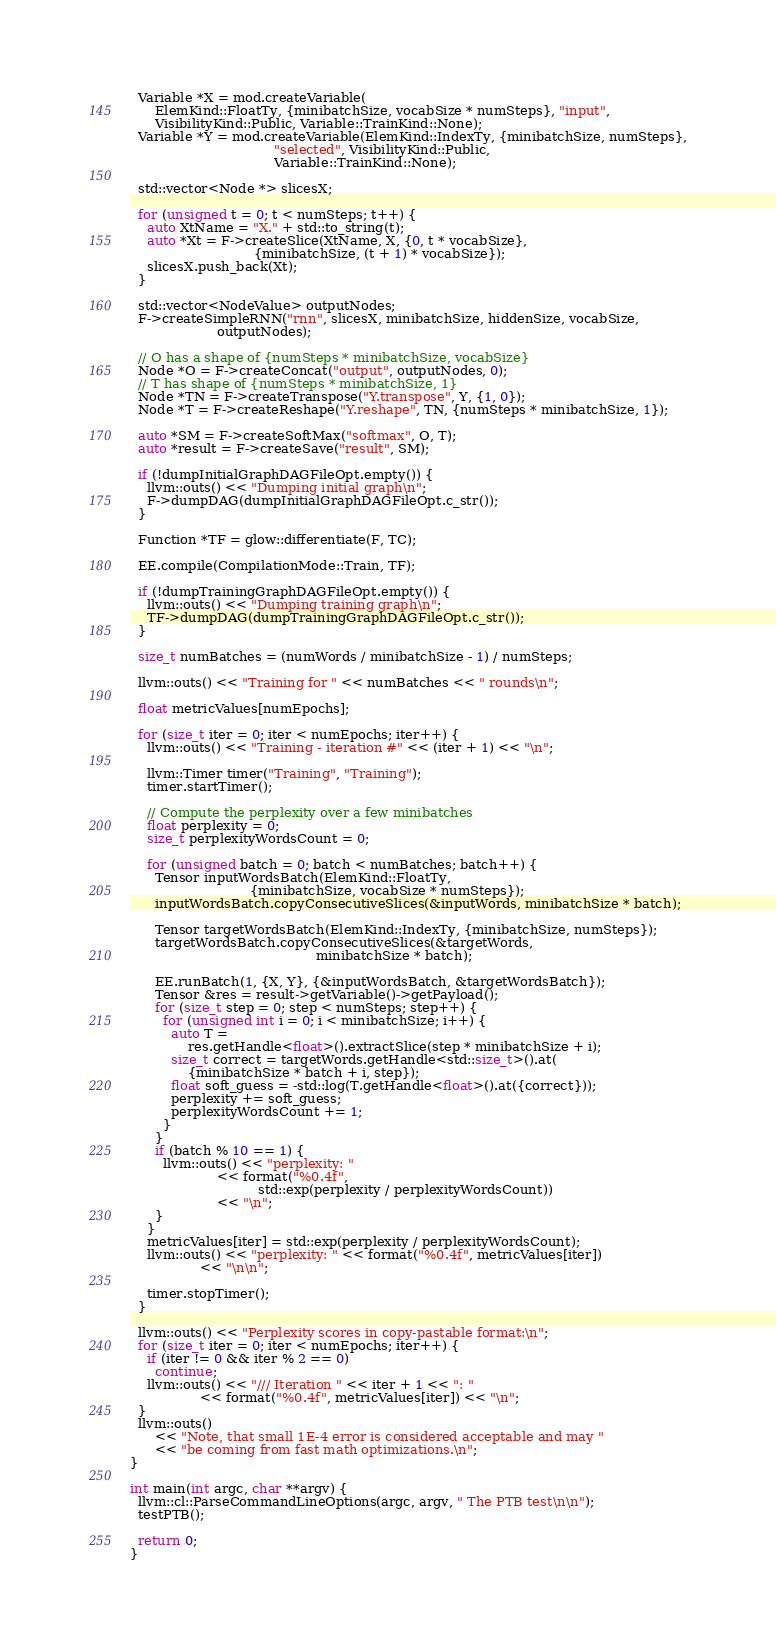<code> <loc_0><loc_0><loc_500><loc_500><_C++_>  Variable *X = mod.createVariable(
      ElemKind::FloatTy, {minibatchSize, vocabSize * numSteps}, "input",
      VisibilityKind::Public, Variable::TrainKind::None);
  Variable *Y = mod.createVariable(ElemKind::IndexTy, {minibatchSize, numSteps},
                                   "selected", VisibilityKind::Public,
                                   Variable::TrainKind::None);

  std::vector<Node *> slicesX;

  for (unsigned t = 0; t < numSteps; t++) {
    auto XtName = "X." + std::to_string(t);
    auto *Xt = F->createSlice(XtName, X, {0, t * vocabSize},
                              {minibatchSize, (t + 1) * vocabSize});
    slicesX.push_back(Xt);
  }

  std::vector<NodeValue> outputNodes;
  F->createSimpleRNN("rnn", slicesX, minibatchSize, hiddenSize, vocabSize,
                     outputNodes);

  // O has a shape of {numSteps * minibatchSize, vocabSize}
  Node *O = F->createConcat("output", outputNodes, 0);
  // T has shape of {numSteps * minibatchSize, 1}
  Node *TN = F->createTranspose("Y.transpose", Y, {1, 0});
  Node *T = F->createReshape("Y.reshape", TN, {numSteps * minibatchSize, 1});

  auto *SM = F->createSoftMax("softmax", O, T);
  auto *result = F->createSave("result", SM);

  if (!dumpInitialGraphDAGFileOpt.empty()) {
    llvm::outs() << "Dumping initial graph\n";
    F->dumpDAG(dumpInitialGraphDAGFileOpt.c_str());
  }

  Function *TF = glow::differentiate(F, TC);

  EE.compile(CompilationMode::Train, TF);

  if (!dumpTrainingGraphDAGFileOpt.empty()) {
    llvm::outs() << "Dumping training graph\n";
    TF->dumpDAG(dumpTrainingGraphDAGFileOpt.c_str());
  }

  size_t numBatches = (numWords / minibatchSize - 1) / numSteps;

  llvm::outs() << "Training for " << numBatches << " rounds\n";

  float metricValues[numEpochs];

  for (size_t iter = 0; iter < numEpochs; iter++) {
    llvm::outs() << "Training - iteration #" << (iter + 1) << "\n";

    llvm::Timer timer("Training", "Training");
    timer.startTimer();

    // Compute the perplexity over a few minibatches
    float perplexity = 0;
    size_t perplexityWordsCount = 0;

    for (unsigned batch = 0; batch < numBatches; batch++) {
      Tensor inputWordsBatch(ElemKind::FloatTy,
                             {minibatchSize, vocabSize * numSteps});
      inputWordsBatch.copyConsecutiveSlices(&inputWords, minibatchSize * batch);

      Tensor targetWordsBatch(ElemKind::IndexTy, {minibatchSize, numSteps});
      targetWordsBatch.copyConsecutiveSlices(&targetWords,
                                             minibatchSize * batch);

      EE.runBatch(1, {X, Y}, {&inputWordsBatch, &targetWordsBatch});
      Tensor &res = result->getVariable()->getPayload();
      for (size_t step = 0; step < numSteps; step++) {
        for (unsigned int i = 0; i < minibatchSize; i++) {
          auto T =
              res.getHandle<float>().extractSlice(step * minibatchSize + i);
          size_t correct = targetWords.getHandle<std::size_t>().at(
              {minibatchSize * batch + i, step});
          float soft_guess = -std::log(T.getHandle<float>().at({correct}));
          perplexity += soft_guess;
          perplexityWordsCount += 1;
        }
      }
      if (batch % 10 == 1) {
        llvm::outs() << "perplexity: "
                     << format("%0.4f",
                               std::exp(perplexity / perplexityWordsCount))
                     << "\n";
      }
    }
    metricValues[iter] = std::exp(perplexity / perplexityWordsCount);
    llvm::outs() << "perplexity: " << format("%0.4f", metricValues[iter])
                 << "\n\n";

    timer.stopTimer();
  }

  llvm::outs() << "Perplexity scores in copy-pastable format:\n";
  for (size_t iter = 0; iter < numEpochs; iter++) {
    if (iter != 0 && iter % 2 == 0)
      continue;
    llvm::outs() << "/// Iteration " << iter + 1 << ": "
                 << format("%0.4f", metricValues[iter]) << "\n";
  }
  llvm::outs()
      << "Note, that small 1E-4 error is considered acceptable and may "
      << "be coming from fast math optimizations.\n";
}

int main(int argc, char **argv) {
  llvm::cl::ParseCommandLineOptions(argc, argv, " The PTB test\n\n");
  testPTB();

  return 0;
}
</code> 